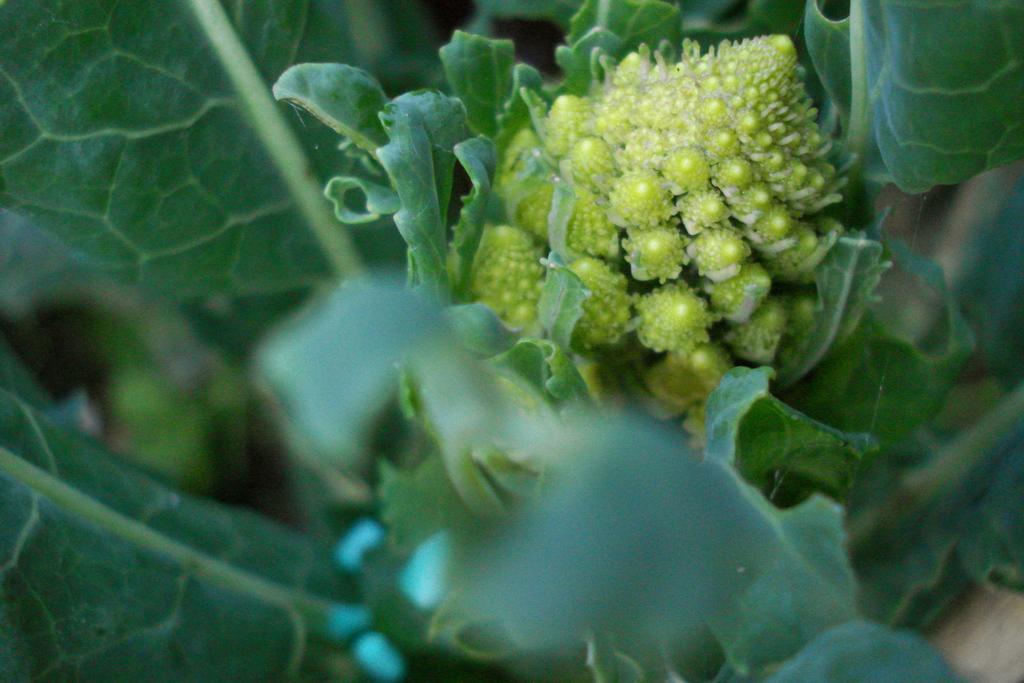In one or two sentences, can you explain what this image depicts? In this image I can see there are leaves. And in that there is a broccoli. 